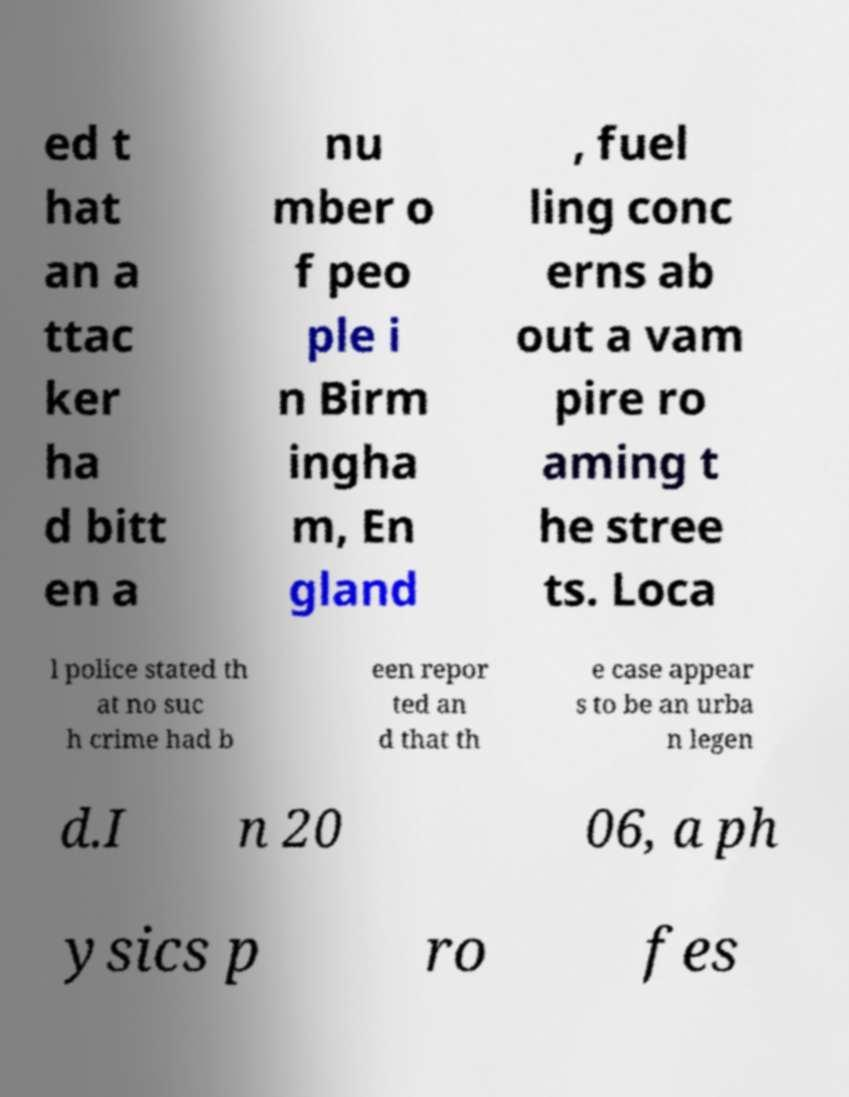Could you assist in decoding the text presented in this image and type it out clearly? ed t hat an a ttac ker ha d bitt en a nu mber o f peo ple i n Birm ingha m, En gland , fuel ling conc erns ab out a vam pire ro aming t he stree ts. Loca l police stated th at no suc h crime had b een repor ted an d that th e case appear s to be an urba n legen d.I n 20 06, a ph ysics p ro fes 